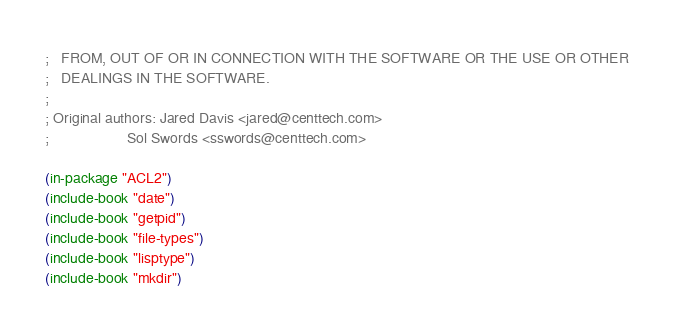<code> <loc_0><loc_0><loc_500><loc_500><_Lisp_>;   FROM, OUT OF OR IN CONNECTION WITH THE SOFTWARE OR THE USE OR OTHER
;   DEALINGS IN THE SOFTWARE.
;
; Original authors: Jared Davis <jared@centtech.com>
;                   Sol Swords <sswords@centtech.com>

(in-package "ACL2")
(include-book "date")
(include-book "getpid")
(include-book "file-types")
(include-book "lisptype")
(include-book "mkdir")

</code> 